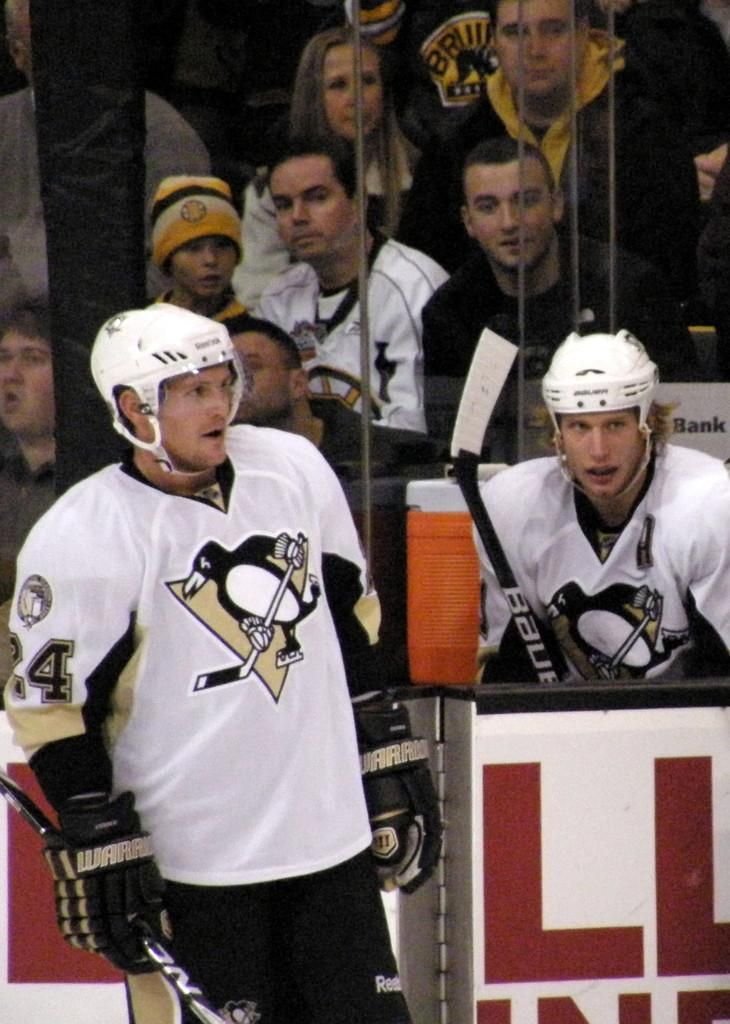Who or what can be seen in the image? There are people in the image. What is the purpose of the name board in the image? The name board in the image is likely used for identification or direction. Can you describe the object at the bottom of the image? Unfortunately, the facts provided do not give enough information to describe the object at the bottom of the image. How many swings are visible in the image? There are no swings present in the image. What type of pin is being used by the people in the image? There is no pin visible in the image. 